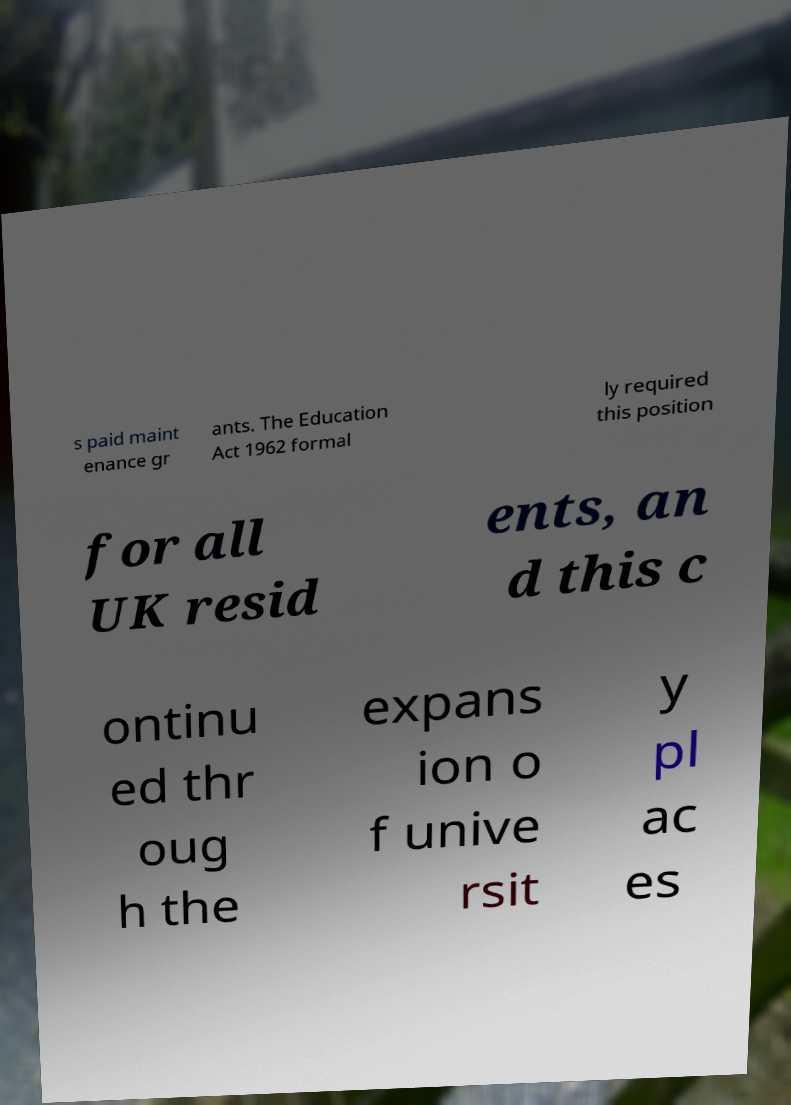Can you accurately transcribe the text from the provided image for me? s paid maint enance gr ants. The Education Act 1962 formal ly required this position for all UK resid ents, an d this c ontinu ed thr oug h the expans ion o f unive rsit y pl ac es 